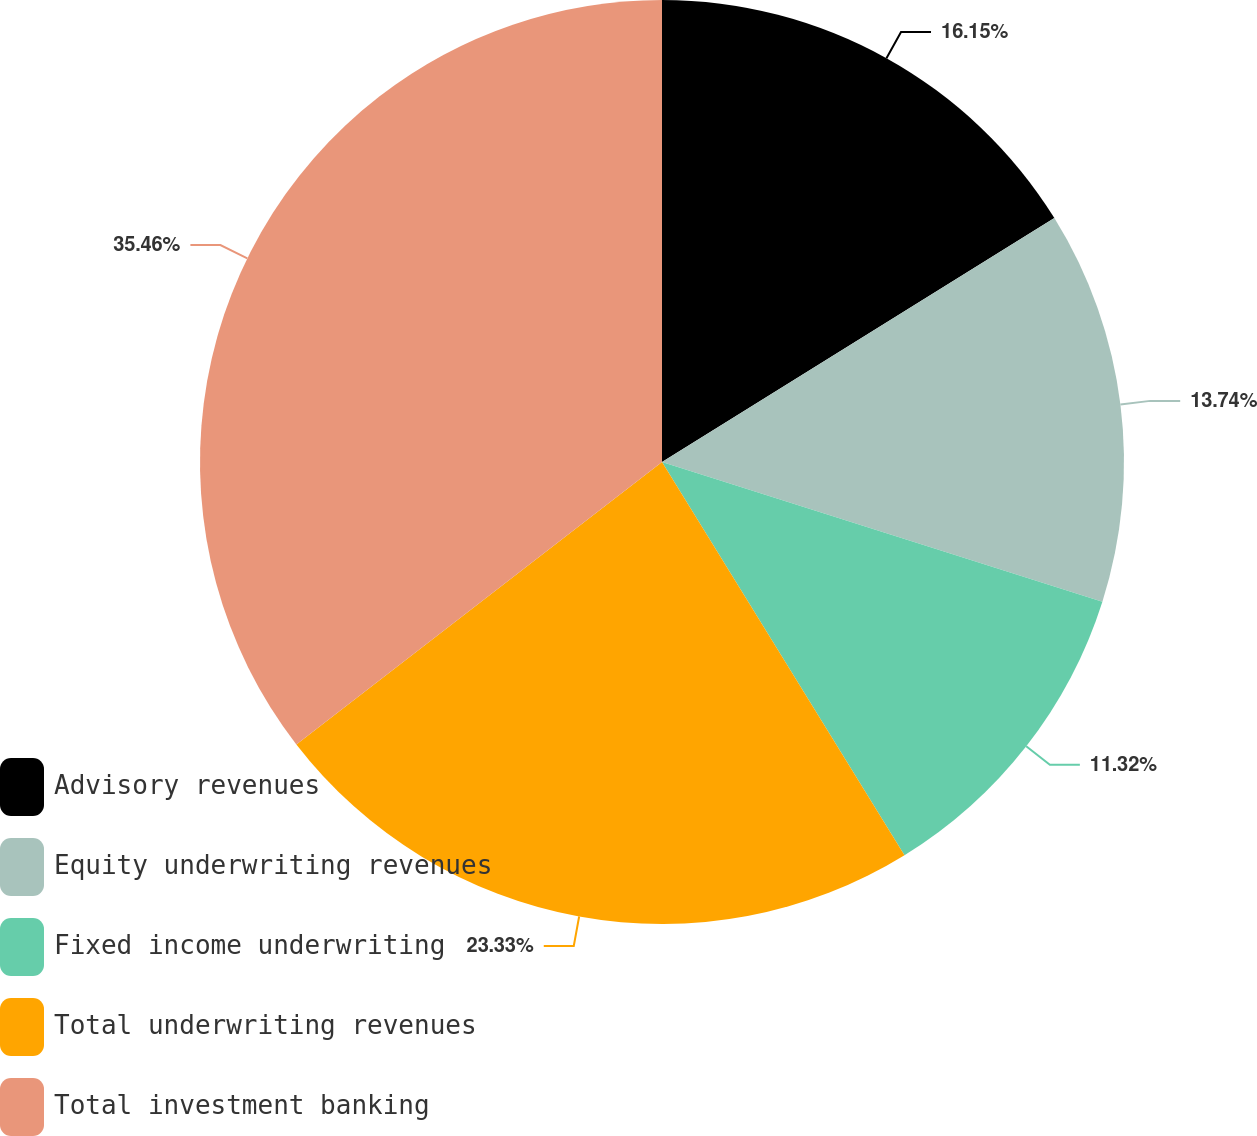<chart> <loc_0><loc_0><loc_500><loc_500><pie_chart><fcel>Advisory revenues<fcel>Equity underwriting revenues<fcel>Fixed income underwriting<fcel>Total underwriting revenues<fcel>Total investment banking<nl><fcel>16.15%<fcel>13.74%<fcel>11.32%<fcel>23.33%<fcel>35.47%<nl></chart> 